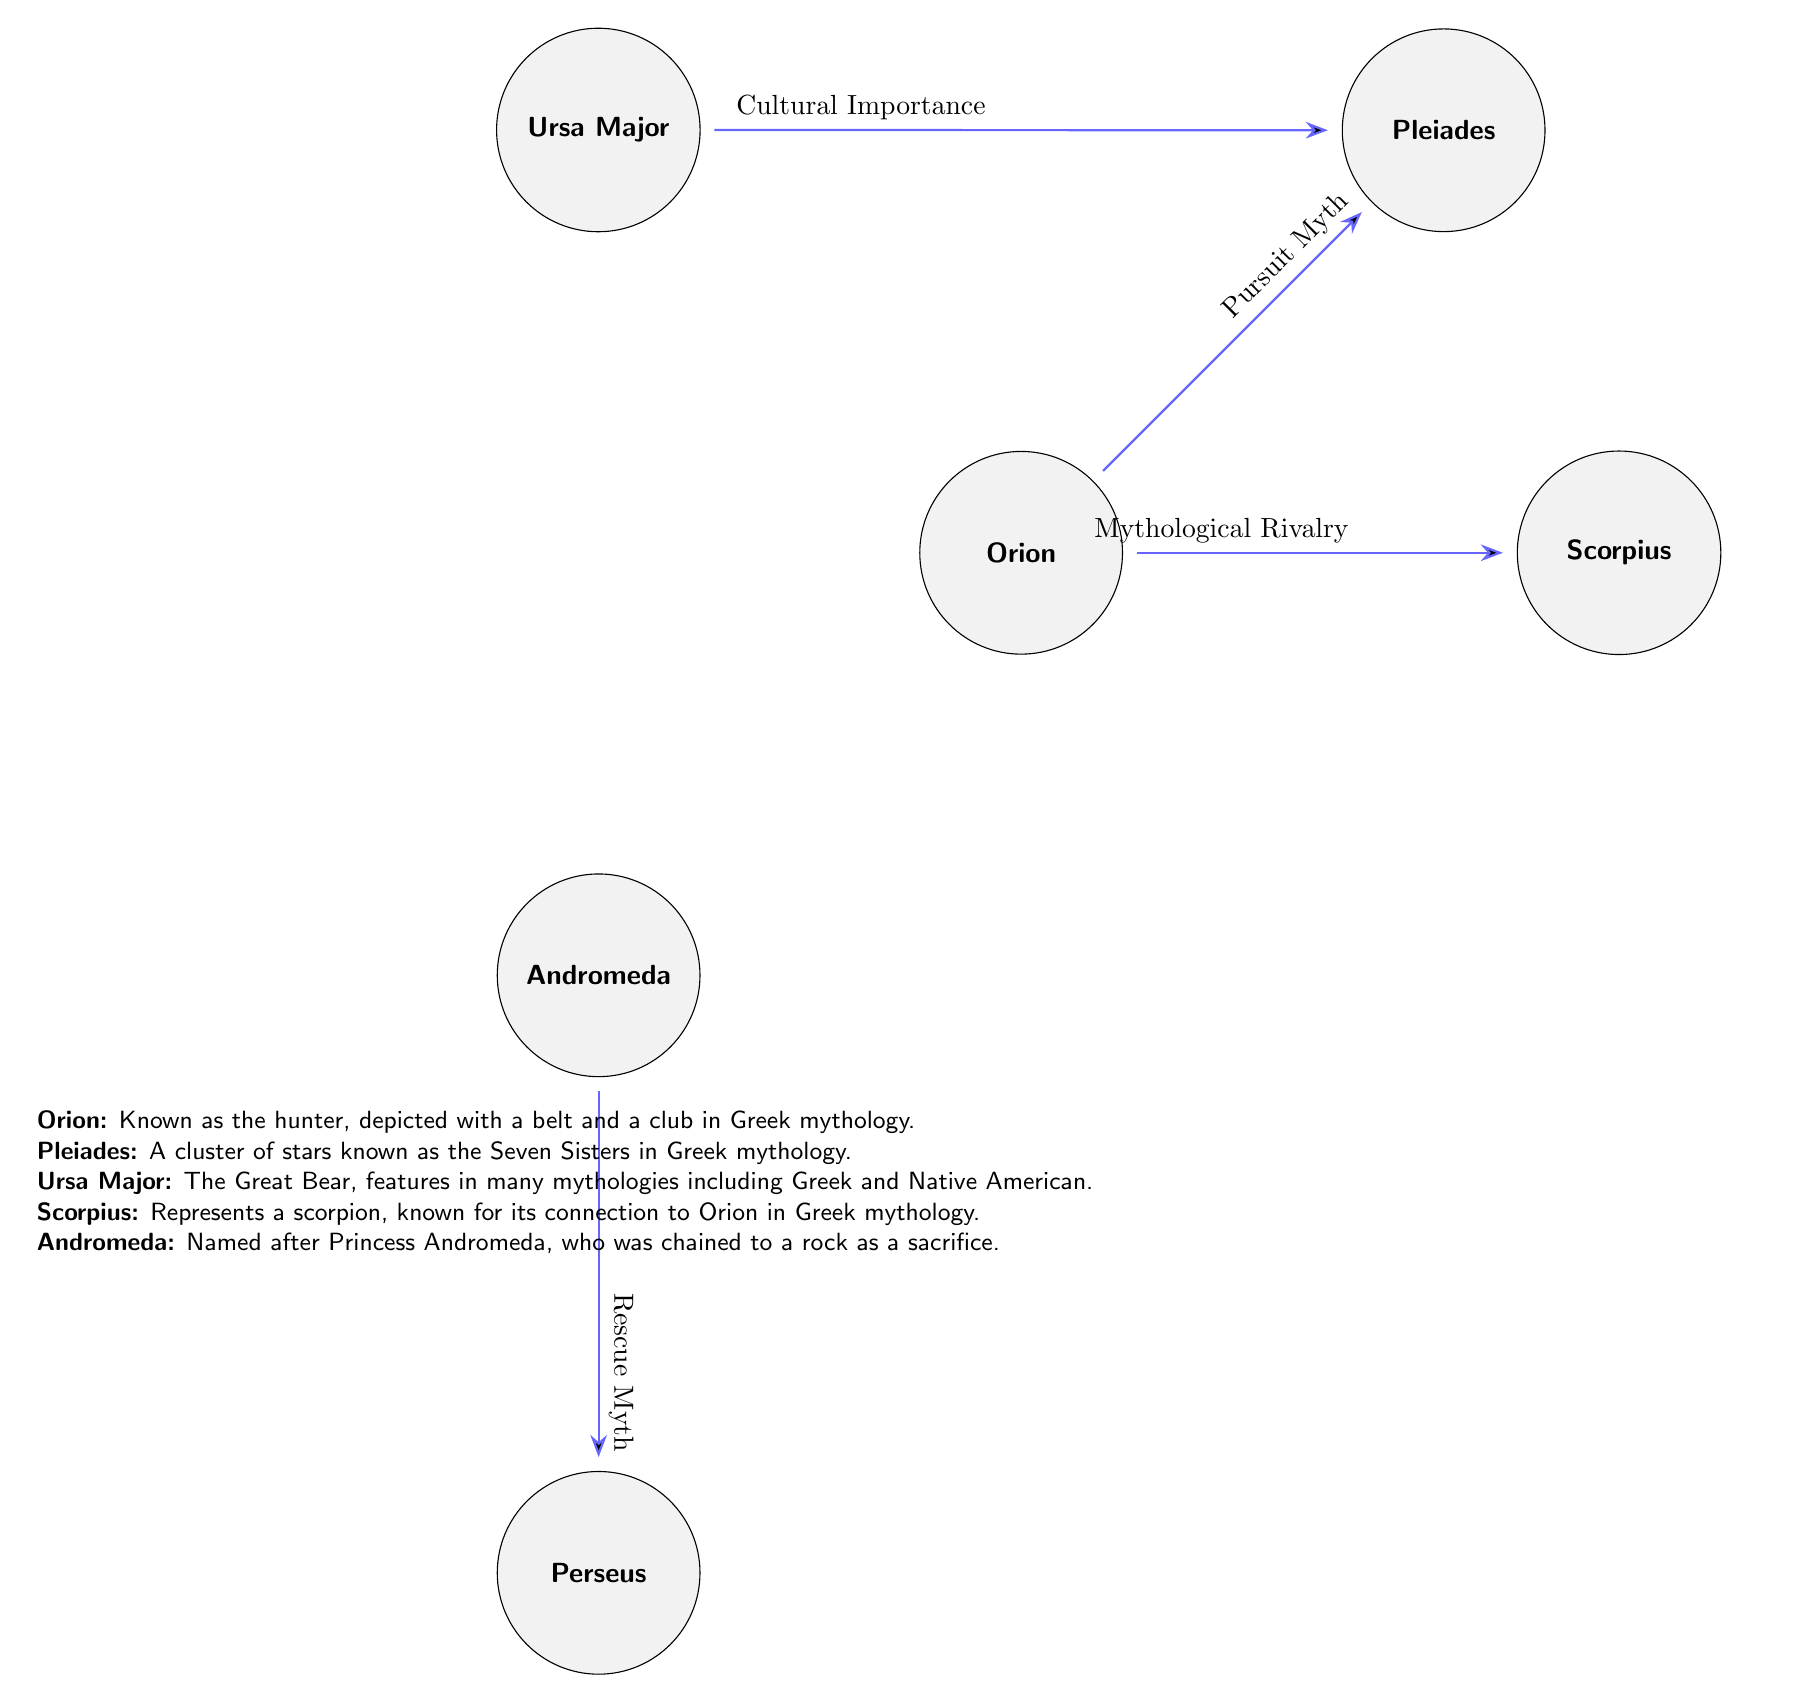What are the constellations shown in the diagram? The diagram features six constellations: Orion, Scorpius, Pleiades, Ursa Major, Andromeda, and Perseus, which are all visually represented as nodes in the diagram.
Answer: Orion, Scorpius, Pleiades, Ursa Major, Andromeda, Perseus How many edges are represented in the diagram? The diagram contains four edges connecting the constellations, showing relationships such as "Mythological Rivalry" and "Rescue Myth." These connections reflect the interactions between constellations.
Answer: 4 What relationship exists between Orion and Scorpius? There is a "Mythological Rivalry" relationship indicated between Orion and Scorpius, which is shown on the diagram by an edge labeled with this connection.
Answer: Mythological Rivalry Which constellation is depicted as a hunter? Orion is depicted as a hunter in the legend as indicated by the description provided below the constellations.
Answer: Orion What constellation is associated with a rescue myth? Andromeda is associated with a "Rescue Myth," which is mentioned in the connections to Perseus, highlighting the story in mythology.
Answer: Andromeda Which constellation connects to both Pleiades and Ursa Major? Ursa Major connects to Pleiades via the "Cultural Importance" relationship, as indicated by the specific edge labeled in the diagram.
Answer: Ursa Major Which constellation represents a scorpion? Scorpius represents a scorpion, as indicated in the descriptions provided under the constellations' node labels.
Answer: Scorpius How many constellations are below Andromeda in the diagram? There is one constellation below Andromeda, which is Perseus, directly connected through an edge labeled "Rescue Myth."
Answer: 1 What mythological role does Pleiades play in relation to Orion? Pleiades is involved in a "Pursuit Myth" as indicated by the edge directed from Orion to Pleiades, suggesting a narrative relationship in mythology.
Answer: Pursuit Myth 